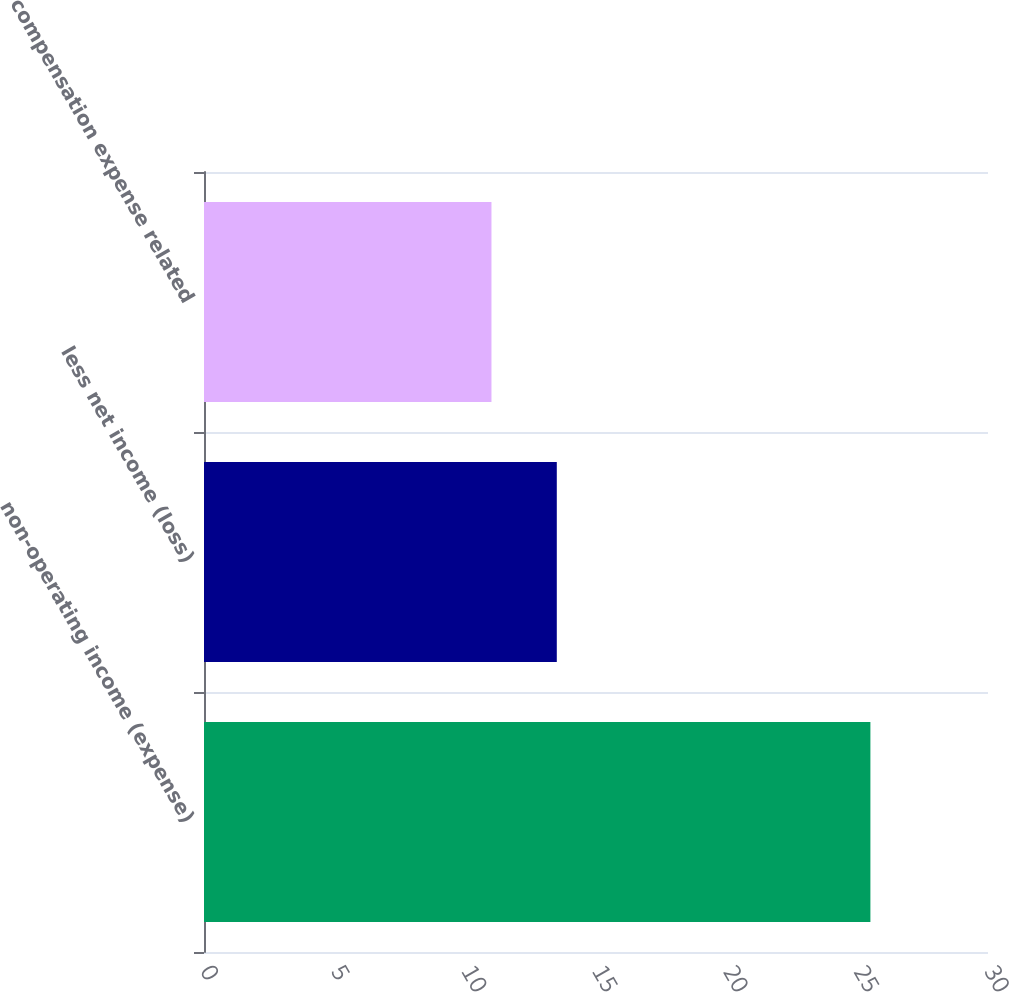Convert chart to OTSL. <chart><loc_0><loc_0><loc_500><loc_500><bar_chart><fcel>non-operating income (expense)<fcel>less net income (loss)<fcel>compensation expense related<nl><fcel>25.5<fcel>13.5<fcel>11<nl></chart> 